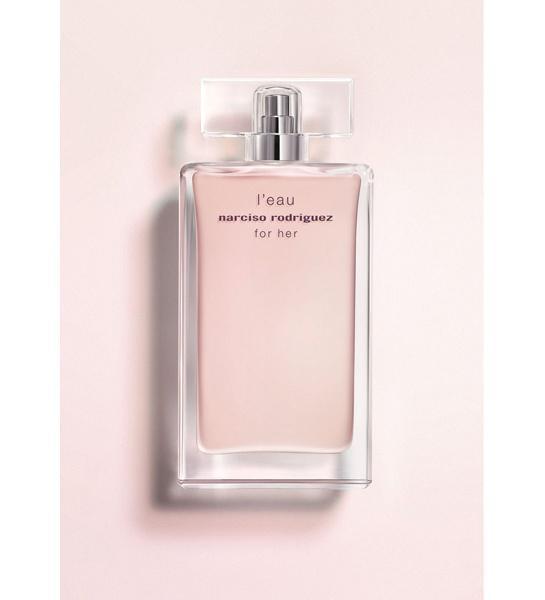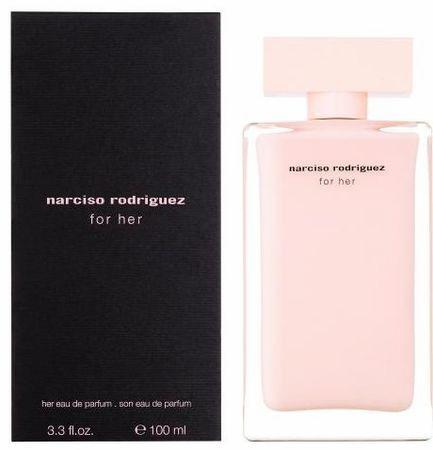The first image is the image on the left, the second image is the image on the right. For the images displayed, is the sentence "The image on the right contains both a bottle and a box." factually correct? Answer yes or no. Yes. 